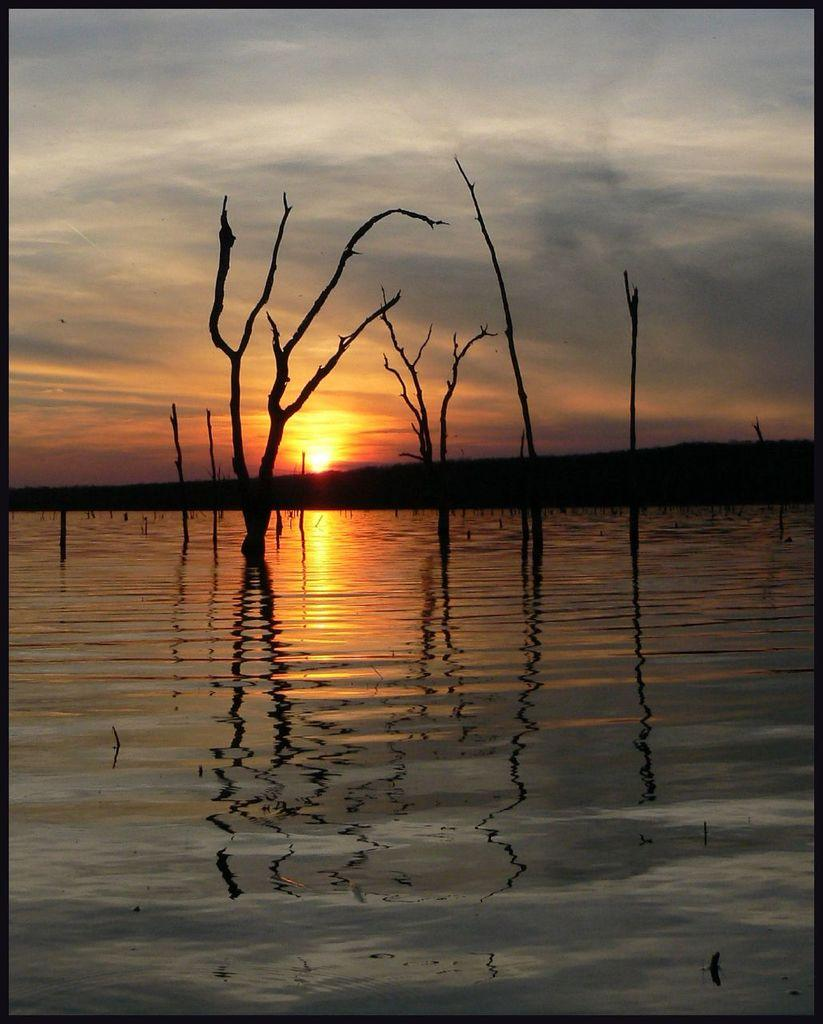What body of water is present in the image? There is a lake in the image. What else can be seen in the sky in the image? The sky is visible in the image. Can you describe any vegetation present in the image? There is a tree stem in the image. What time of day is depicted in the image? The image depicts a sunset. What type of chin can be seen in the image? There is no chin present in the image. What kind of rod is used to catch fish in the image? There is no rod or fishing activity depicted in the image. 